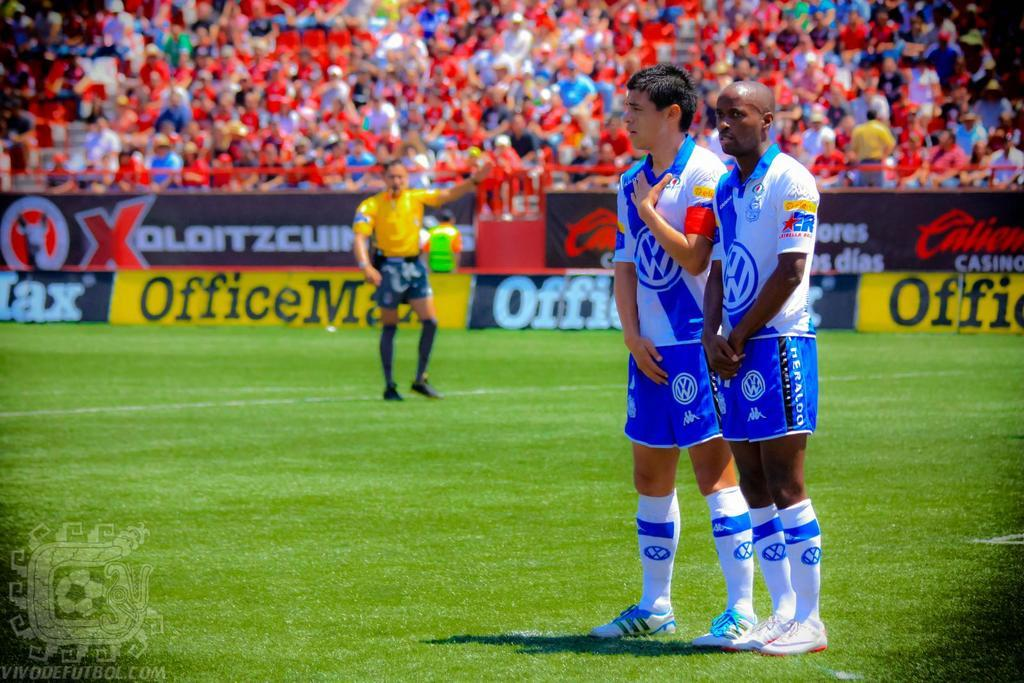How many people are on the ground in the image? There are three persons on the ground in the image. What is the ground covered with? The ground is covered with grass. What can be seen in the image besides the people on the ground? There are hoardings in the image. What is visible in the background of the image? There is a crowd visible in the background. What type of birds can be seen resting on the hoardings in the image? There are no birds visible in the image, and therefore no birds can be seen resting on the hoardings. 